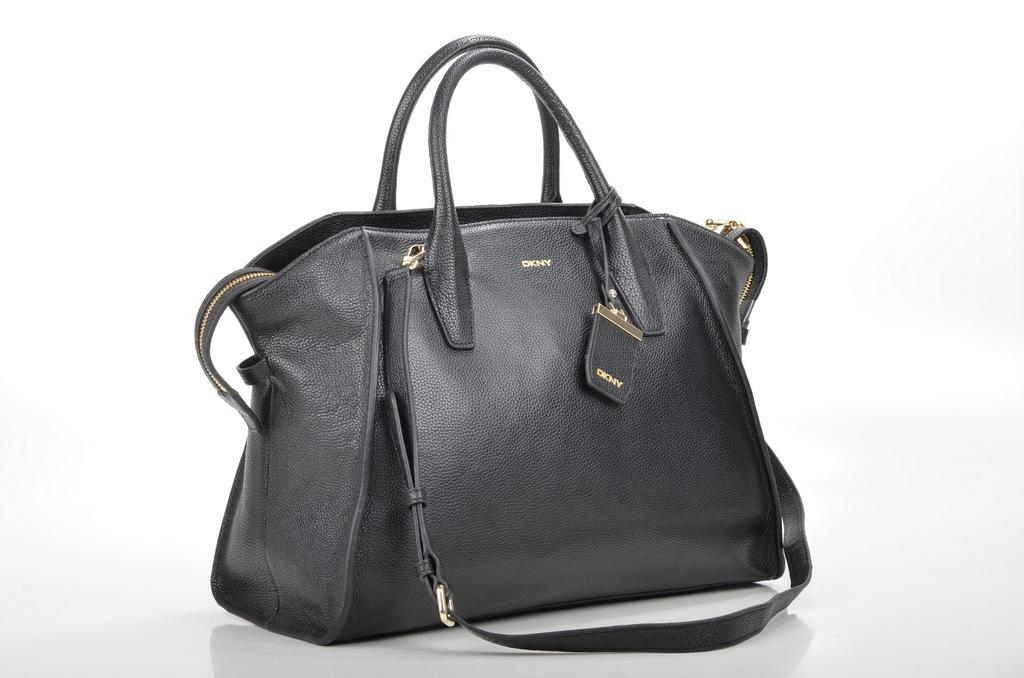What is the color of the bag in the photo? The bag in the photo is black. What type of strap does the bag have? The bag has a black strap. What brand is the bag? The bag has "DKNY" written on it, which indicates it is a DKNY brand bag. What type of skin condition can be seen on the bag in the photo? There is no skin condition present on the bag in the photo, as it is an inanimate object. 